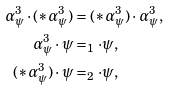Convert formula to latex. <formula><loc_0><loc_0><loc_500><loc_500>\alpha _ { \psi } ^ { 3 } \cdot ( \ast \alpha _ { \psi } ^ { 3 } ) & = ( \ast \alpha _ { \psi } ^ { 3 } ) \cdot \alpha _ { \psi } ^ { 3 } , \\ \alpha _ { \psi } ^ { 3 } \cdot \psi & = _ { 1 } \cdot \psi , \\ ( \ast \alpha _ { \psi } ^ { 3 } ) \cdot \psi & = _ { 2 } \cdot \psi ,</formula> 